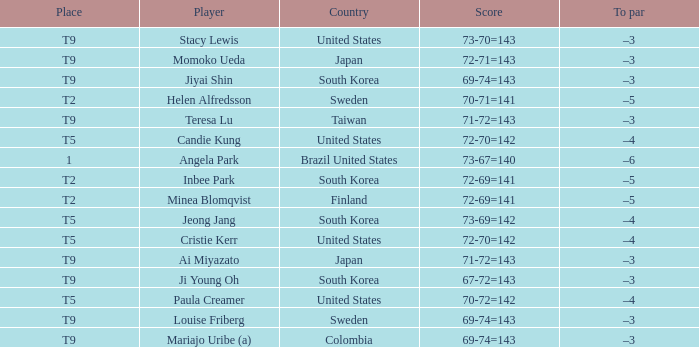Who scored 70-72=142 and positioned themselves at t5? Paula Creamer. 